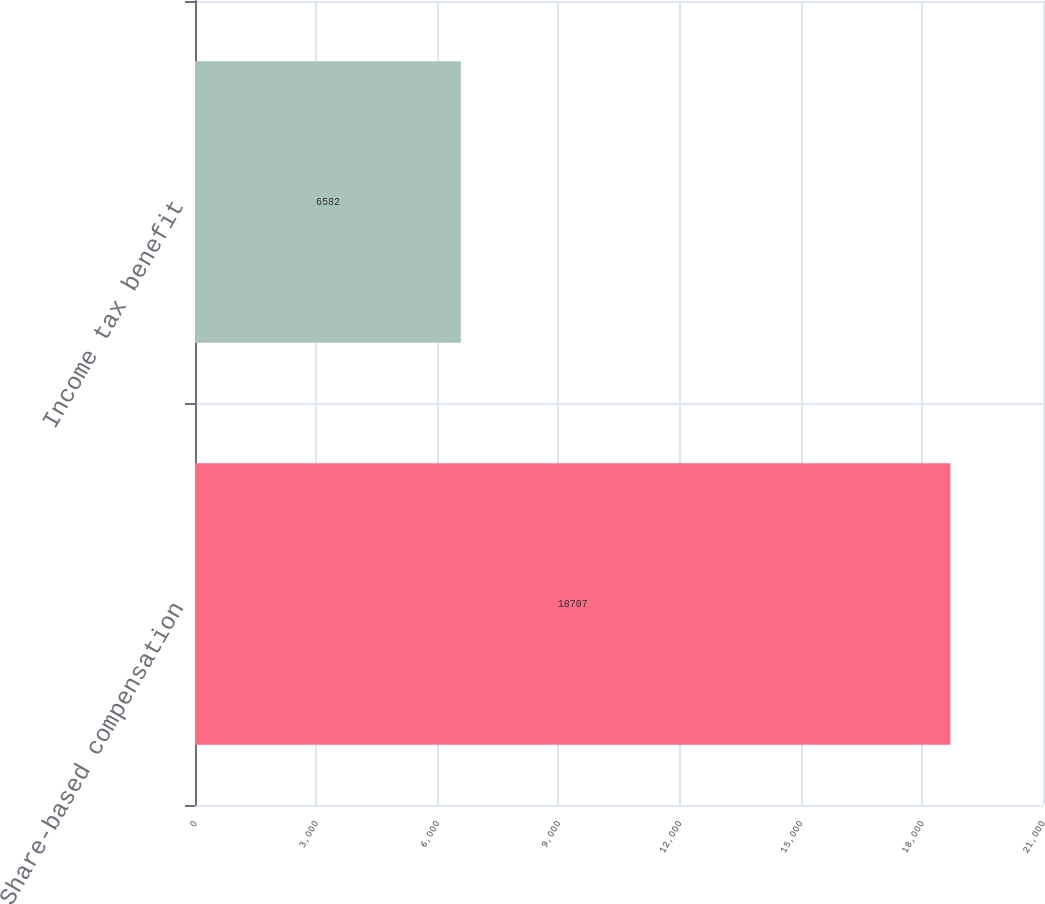Convert chart to OTSL. <chart><loc_0><loc_0><loc_500><loc_500><bar_chart><fcel>Share-based compensation<fcel>Income tax benefit<nl><fcel>18707<fcel>6582<nl></chart> 